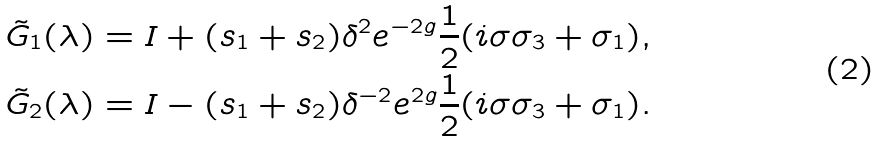<formula> <loc_0><loc_0><loc_500><loc_500>& \tilde { G } _ { 1 } ( \lambda ) = I + ( s _ { 1 } + s _ { 2 } ) \delta ^ { 2 } e ^ { - 2 g } \frac { 1 } { 2 } ( i \sigma \sigma _ { 3 } + \sigma _ { 1 } ) , \\ & \tilde { G } _ { 2 } ( \lambda ) = I - ( s _ { 1 } + s _ { 2 } ) \delta ^ { - 2 } e ^ { 2 g } \frac { 1 } { 2 } ( i \sigma \sigma _ { 3 } + \sigma _ { 1 } ) .</formula> 